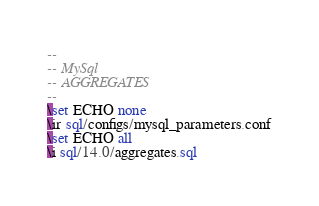Convert code to text. <code><loc_0><loc_0><loc_500><loc_500><_SQL_>--
-- MySql
-- AGGREGATES
--
\set ECHO none
\ir sql/configs/mysql_parameters.conf
\set ECHO all
\i sql/14.0/aggregates.sql
</code> 